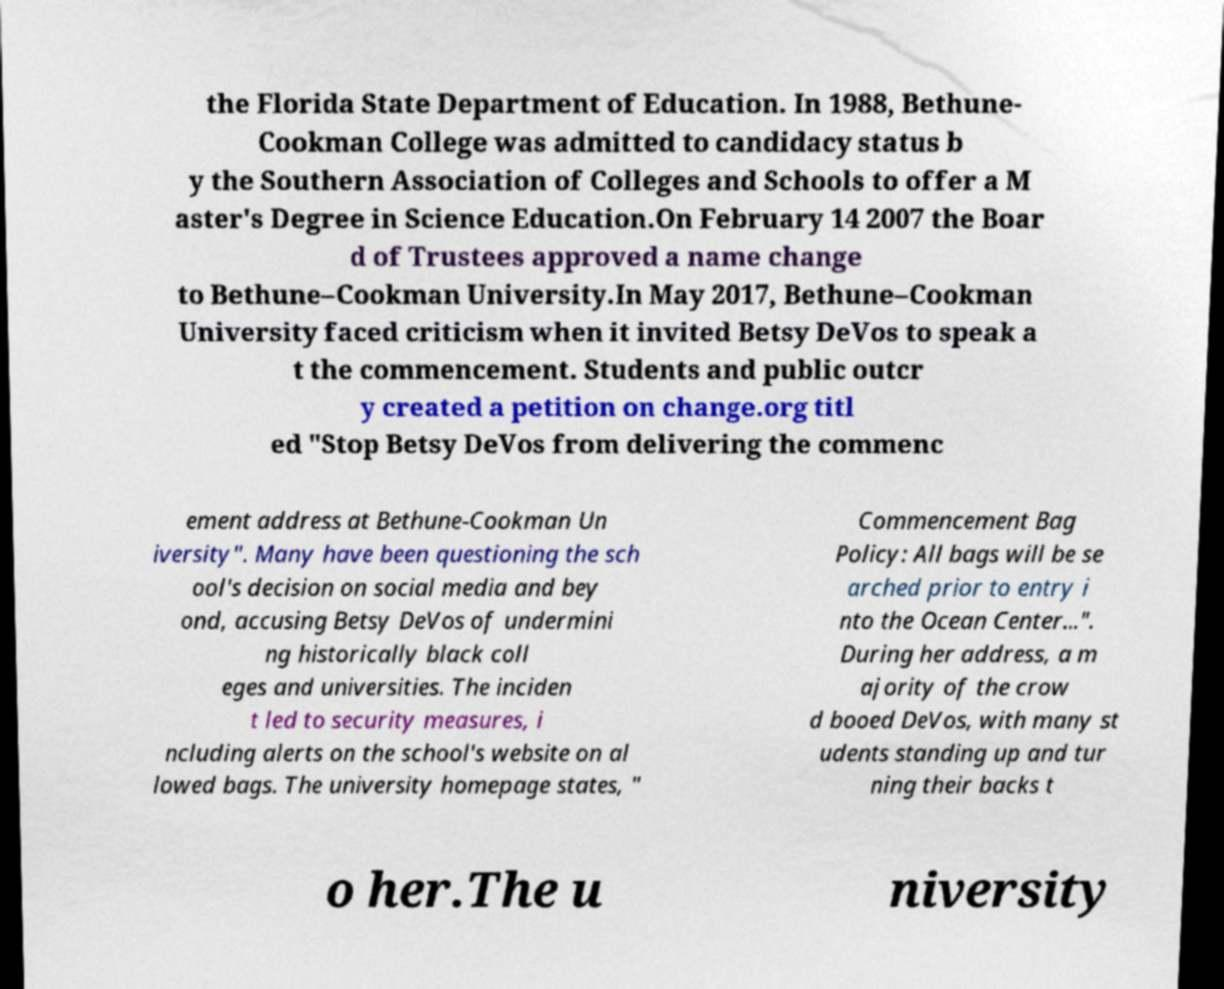Please read and relay the text visible in this image. What does it say? the Florida State Department of Education. In 1988, Bethune- Cookman College was admitted to candidacy status b y the Southern Association of Colleges and Schools to offer a M aster's Degree in Science Education.On February 14 2007 the Boar d of Trustees approved a name change to Bethune–Cookman University.In May 2017, Bethune–Cookman University faced criticism when it invited Betsy DeVos to speak a t the commencement. Students and public outcr y created a petition on change.org titl ed "Stop Betsy DeVos from delivering the commenc ement address at Bethune-Cookman Un iversity". Many have been questioning the sch ool's decision on social media and bey ond, accusing Betsy DeVos of undermini ng historically black coll eges and universities. The inciden t led to security measures, i ncluding alerts on the school's website on al lowed bags. The university homepage states, " Commencement Bag Policy: All bags will be se arched prior to entry i nto the Ocean Center...". During her address, a m ajority of the crow d booed DeVos, with many st udents standing up and tur ning their backs t o her.The u niversity 